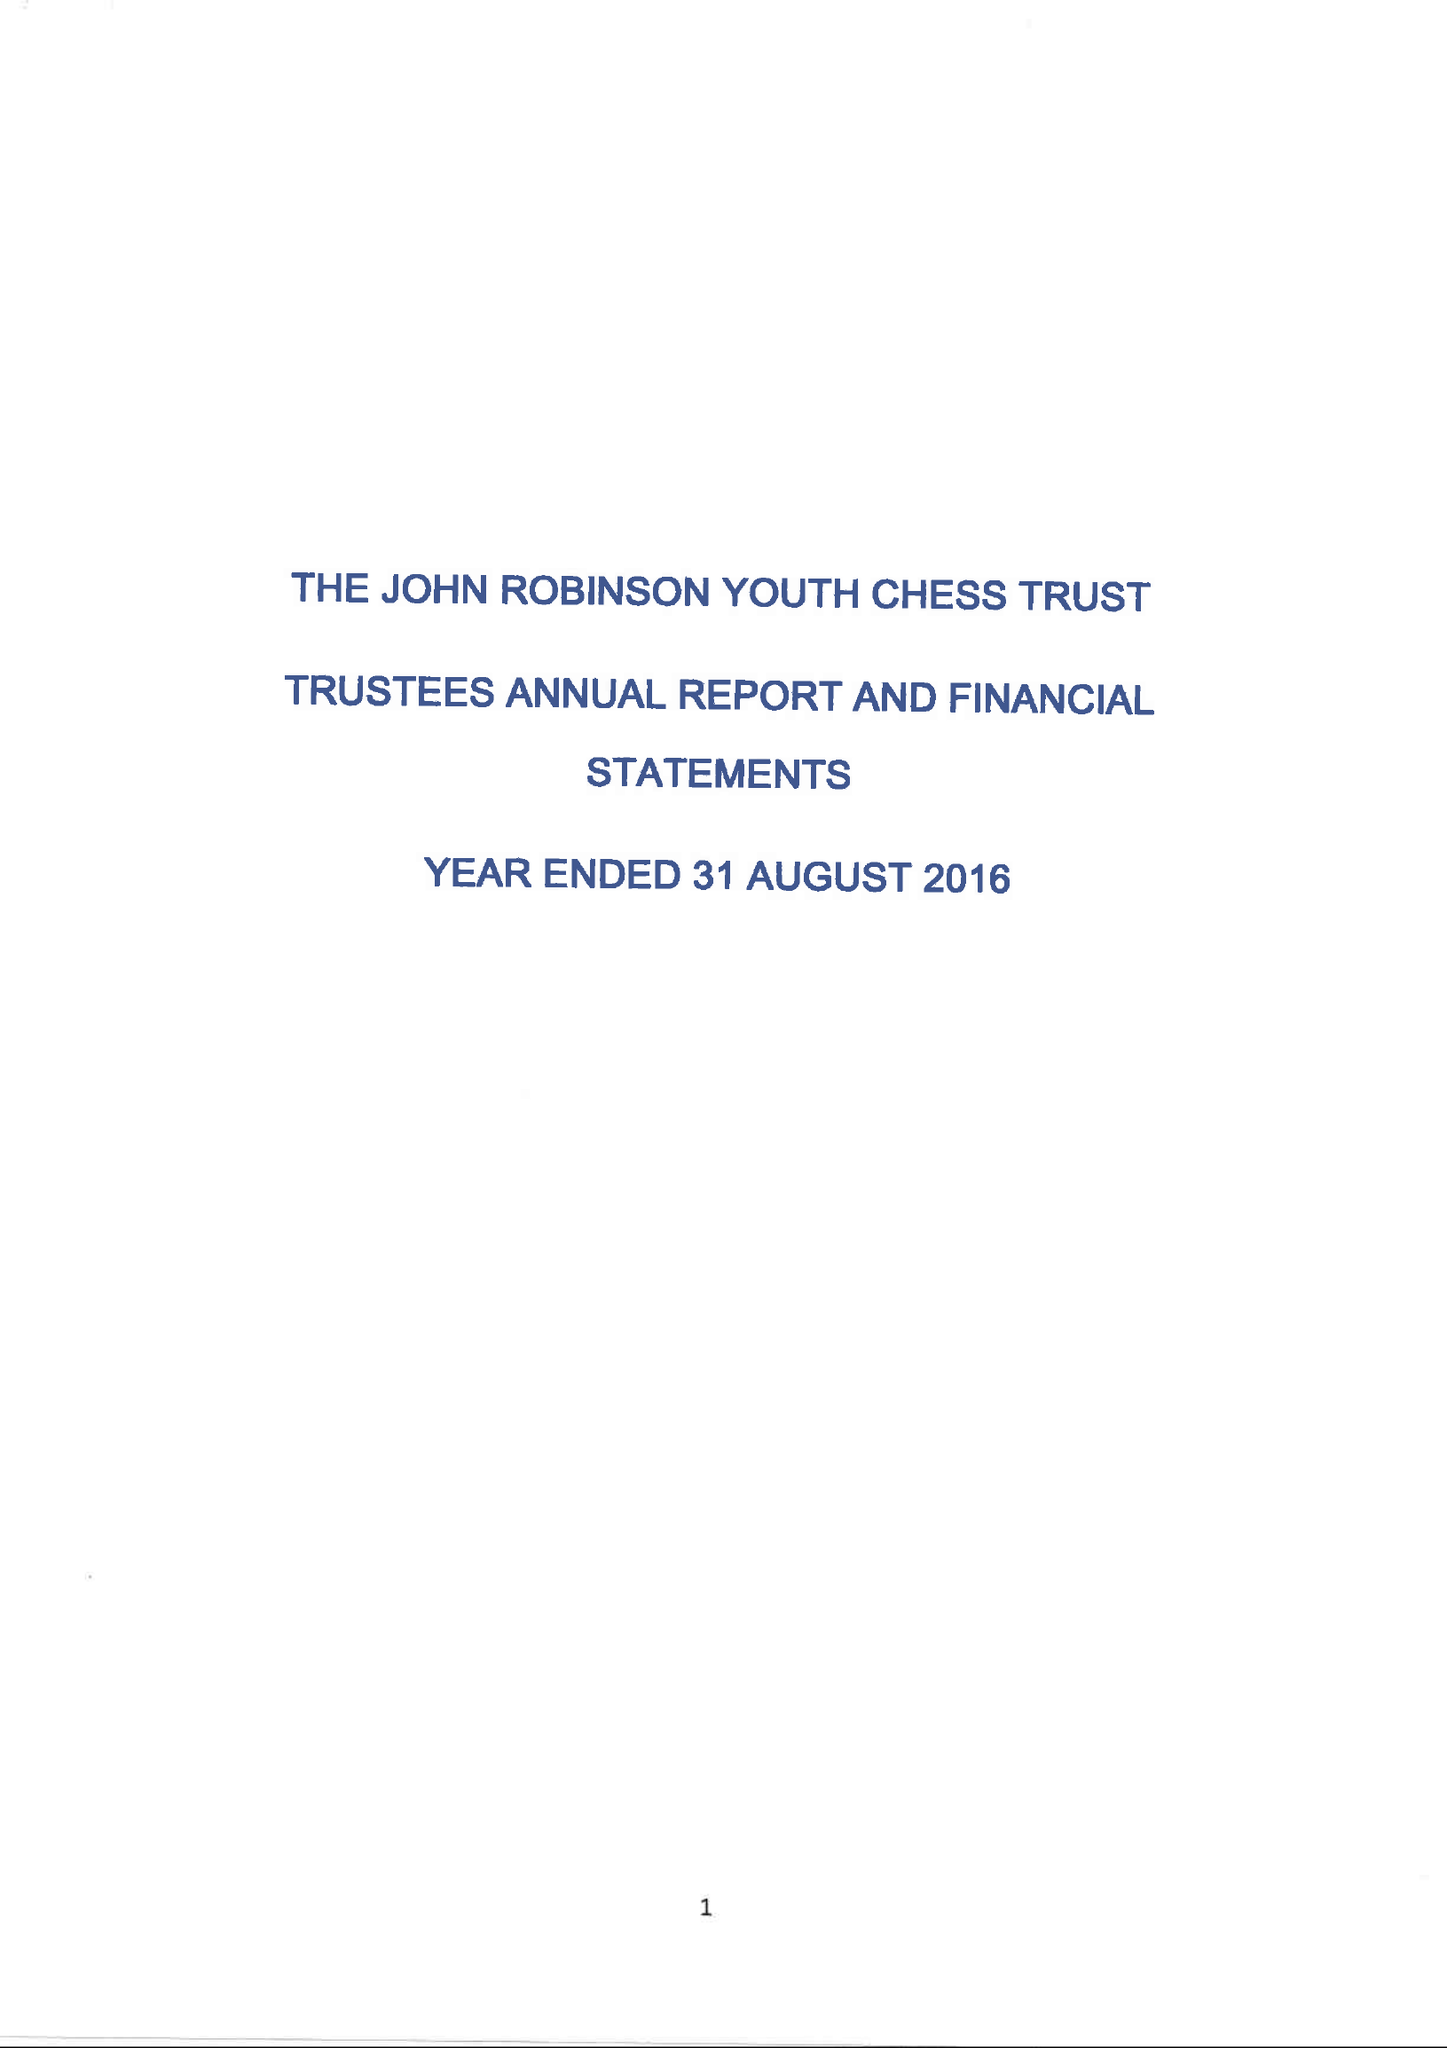What is the value for the address__post_town?
Answer the question using a single word or phrase. CRAWLEY 